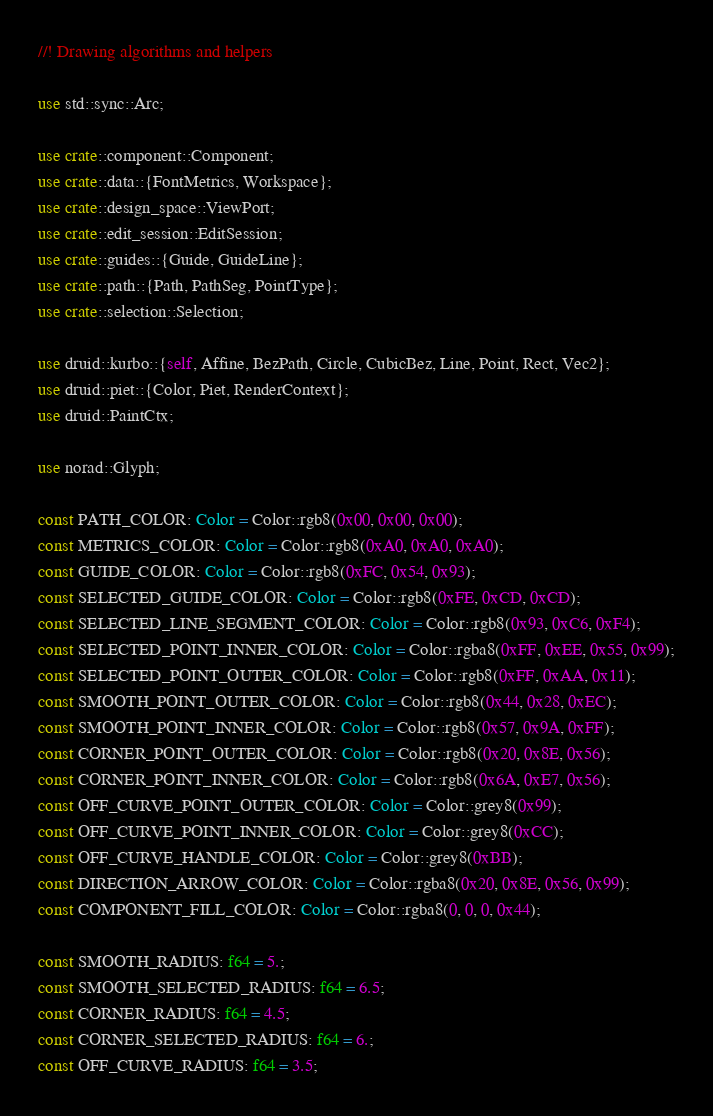<code> <loc_0><loc_0><loc_500><loc_500><_Rust_>//! Drawing algorithms and helpers

use std::sync::Arc;

use crate::component::Component;
use crate::data::{FontMetrics, Workspace};
use crate::design_space::ViewPort;
use crate::edit_session::EditSession;
use crate::guides::{Guide, GuideLine};
use crate::path::{Path, PathSeg, PointType};
use crate::selection::Selection;

use druid::kurbo::{self, Affine, BezPath, Circle, CubicBez, Line, Point, Rect, Vec2};
use druid::piet::{Color, Piet, RenderContext};
use druid::PaintCtx;

use norad::Glyph;

const PATH_COLOR: Color = Color::rgb8(0x00, 0x00, 0x00);
const METRICS_COLOR: Color = Color::rgb8(0xA0, 0xA0, 0xA0);
const GUIDE_COLOR: Color = Color::rgb8(0xFC, 0x54, 0x93);
const SELECTED_GUIDE_COLOR: Color = Color::rgb8(0xFE, 0xCD, 0xCD);
const SELECTED_LINE_SEGMENT_COLOR: Color = Color::rgb8(0x93, 0xC6, 0xF4);
const SELECTED_POINT_INNER_COLOR: Color = Color::rgba8(0xFF, 0xEE, 0x55, 0x99);
const SELECTED_POINT_OUTER_COLOR: Color = Color::rgb8(0xFF, 0xAA, 0x11);
const SMOOTH_POINT_OUTER_COLOR: Color = Color::rgb8(0x44, 0x28, 0xEC);
const SMOOTH_POINT_INNER_COLOR: Color = Color::rgb8(0x57, 0x9A, 0xFF);
const CORNER_POINT_OUTER_COLOR: Color = Color::rgb8(0x20, 0x8E, 0x56);
const CORNER_POINT_INNER_COLOR: Color = Color::rgb8(0x6A, 0xE7, 0x56);
const OFF_CURVE_POINT_OUTER_COLOR: Color = Color::grey8(0x99);
const OFF_CURVE_POINT_INNER_COLOR: Color = Color::grey8(0xCC);
const OFF_CURVE_HANDLE_COLOR: Color = Color::grey8(0xBB);
const DIRECTION_ARROW_COLOR: Color = Color::rgba8(0x20, 0x8E, 0x56, 0x99);
const COMPONENT_FILL_COLOR: Color = Color::rgba8(0, 0, 0, 0x44);

const SMOOTH_RADIUS: f64 = 5.;
const SMOOTH_SELECTED_RADIUS: f64 = 6.5;
const CORNER_RADIUS: f64 = 4.5;
const CORNER_SELECTED_RADIUS: f64 = 6.;
const OFF_CURVE_RADIUS: f64 = 3.5;</code> 